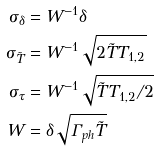<formula> <loc_0><loc_0><loc_500><loc_500>\sigma _ { \delta } & = W ^ { - 1 } \delta \\ \sigma _ { \tilde { T } } & = W ^ { - 1 } \sqrt { 2 \tilde { T } T _ { 1 , 2 } } \\ \sigma _ { \tau } & = W ^ { - 1 } \sqrt { \tilde { T } T _ { 1 , 2 } / 2 } \\ W & = \delta \sqrt { \Gamma _ { p h } \tilde { T } }</formula> 